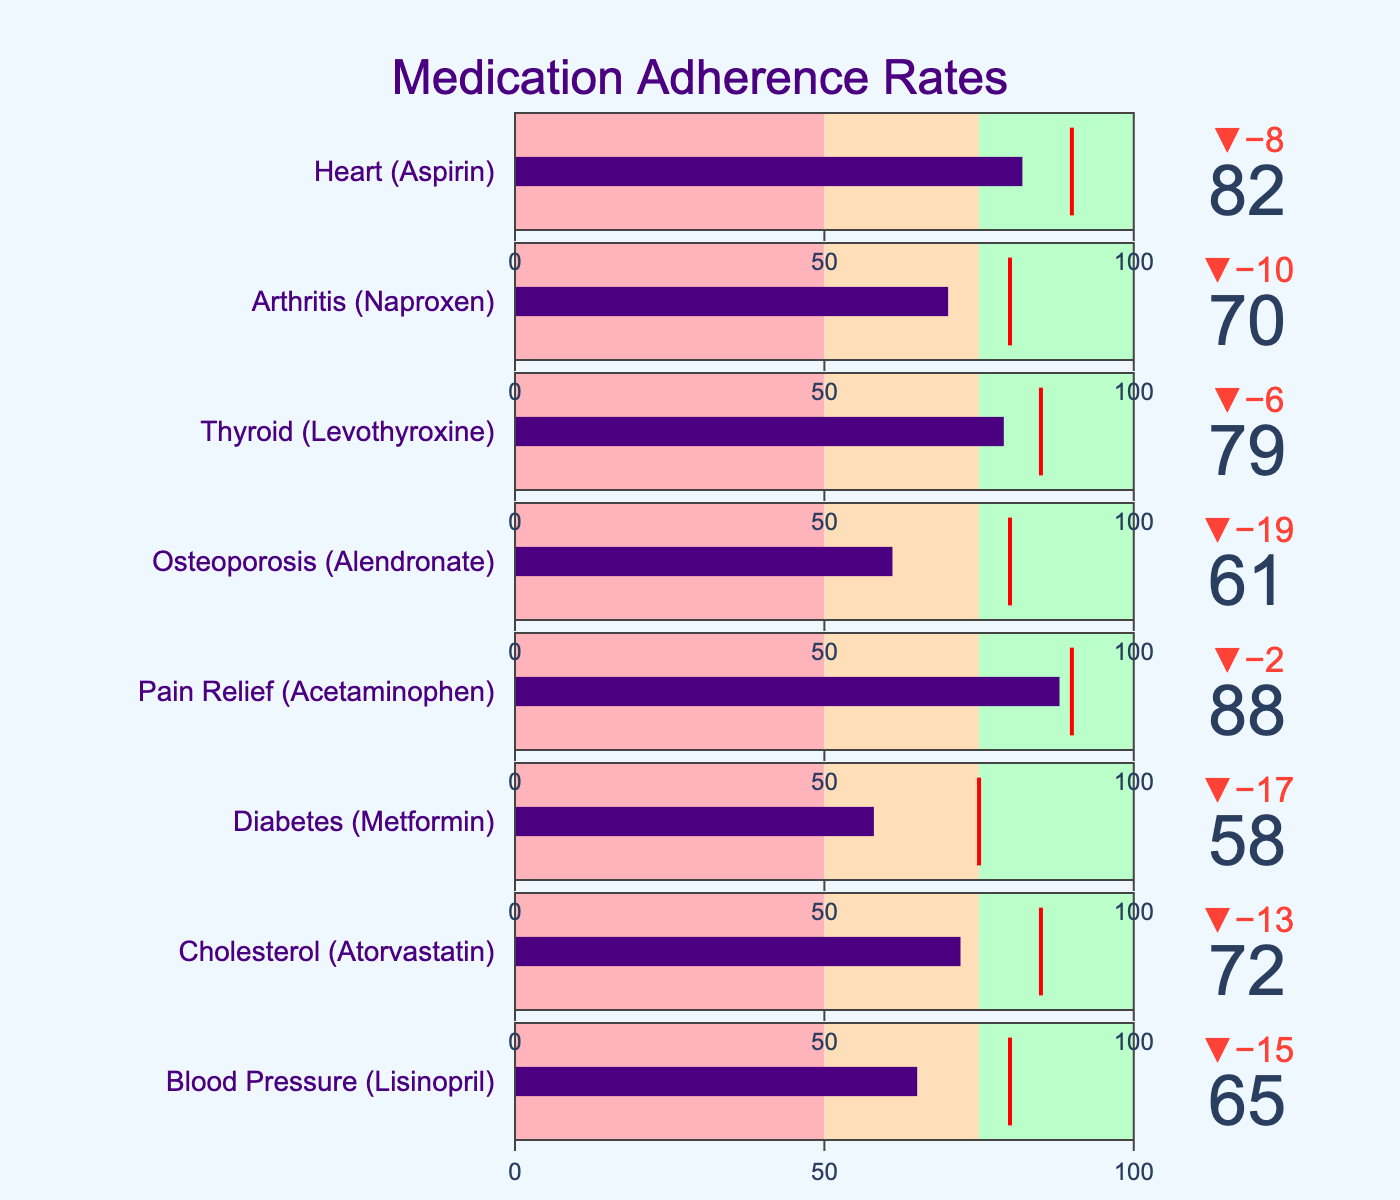What is the highest target adherence rate for any medication in the chart? Looking at the chart, the highest target adherence rate appears next to Pain Relief (Acetaminophen) and Heart (Aspirin), both of which have a target of 90.
Answer: 90 Which medication type has the lowest actual adherence rate? By examining the bullet chart, Diabetes (Metformin) has the lowest actual adherence rate, which is 58.
Answer: Diabetes (Metformin) How much is the difference between the actual adherence and the target adherence for Blood Pressure (Lisinopril)? The actual adherence for Blood Pressure (Lisinopril) is 65, and the target is 80. The difference would be 80 - 65 = 15.
Answer: 15 What is the median actual adherence rate for the medications listed? To find the median, list the actual adherence rates in order: 58, 61, 65, 70, 72, 79, 82, 88. The median value is the average of the two middle values, 70 and 72. Hence (70 + 72) / 2 = 71.
Answer: 71 Which medications have exceeded 80% in actual adherence rates? From the chart, the medications exceeding 80% actual adherence are Pain Relief (Acetaminophen) with 88% and Heart (Aspirin) with 82%.
Answer: Pain Relief (Acetaminophen), Heart (Aspirin) How close is the actual adherence rate of Thyroid (Levothyroxine) compared to its target adherence? The actual adherence for Thyroid (Levothyroxine) is 79, compared to its target of 85. The difference is 85 - 79 = 6.
Answer: 6 Between Cholesterol (Atorvastatin) and Arthritis (Naproxen), which has a higher actual adherence rate? Cholesterol (Atorvastatin) has an actual adherence rate of 72, while Arthritis (Naproxen) has a rate of 70. Hence, Cholesterol (Atorvastatin) has a higher rate.
Answer: Cholesterol (Atorvastatin) What percentage of the medications have an actual adherence rate below the target adherence rate? All seven medications have actual adherence rates below their target rates. Given there are 8 medications in total, the percentage would be (7/8) * 100 = 87.5%.
Answer: 87.5% Which medication type is closest to reaching its target adherence? Pain Relief (Acetaminophen) has an actual adherence rate of 88, compared to its target of 90, making it 2 points away, which is the smallest gap compared to the others.
Answer: Pain Relief (Acetaminophen) What is the average target adherence rate for all medications? Adding up the target adherence rates (80, 85, 75, 90, 80, 85, 80, 90), which sums up to 665, divided by the 8 medication types gives us an average of 665 / 8 = 83.125.
Answer: 83.125 